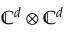<formula> <loc_0><loc_0><loc_500><loc_500>\mathbb { C } ^ { d } \otimes \mathbb { C } ^ { d }</formula> 